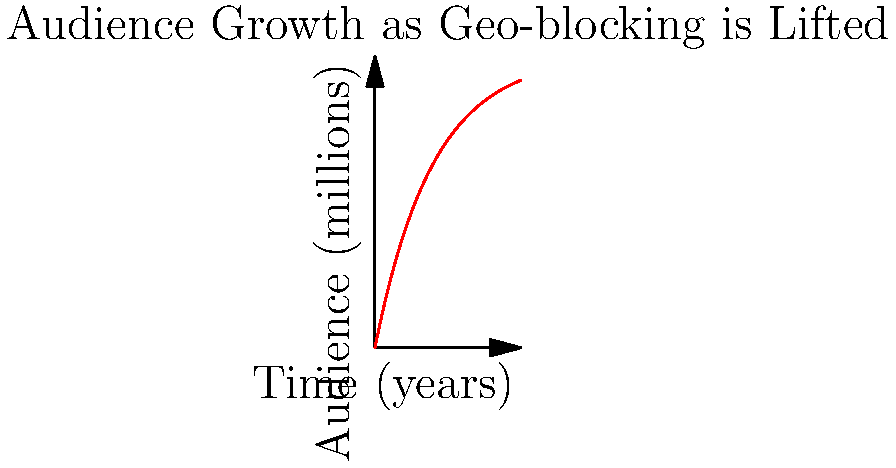As a digital media executive, you're analyzing the impact of gradually lifting geo-blocking restrictions on your platform's audience reach. The graph shows the potential audience growth over time as restrictions are removed. The function describing this growth is given by $A(t) = 10(1-e^{-0.5t})$, where $A$ is the audience size in millions and $t$ is time in years. Calculate the total potential audience reached over the first 5 years, represented by the area under the curve from $t=0$ to $t=5$. To find the total potential audience reached over 5 years, we need to calculate the definite integral of $A(t)$ from 0 to 5.

1) The integral we need to evaluate is:
   $$\int_0^5 10(1-e^{-0.5t}) dt$$

2) Let's split this into two parts:
   $$10\int_0^5 dt - 10\int_0^5 e^{-0.5t} dt$$

3) The first part is straightforward:
   $$10t|_0^5 = 50$$

4) For the second part, we use u-substitution:
   Let $u = -0.5t$, then $du = -0.5dt$ or $dt = -2du$
   When $t=0$, $u=0$; when $t=5$, $u=-2.5$

   $$-20\int_0^{-2.5} e^u du = -20[e^u]_0^{-2.5} = -20(e^{-2.5} - 1)$$

5) Combining the results:
   $$50 - (-20(e^{-2.5} - 1)) = 50 + 20(e^{-2.5} - 1)$$

6) Simplify:
   $$50 + 20e^{-2.5} - 20 = 30 + 20e^{-2.5}$$

7) Calculate the final value:
   $$30 + 20 * 0.0821 = 31.642$$

Therefore, the total potential audience reached over 5 years is approximately 31.642 million viewer-years.
Answer: 31.642 million viewer-years 